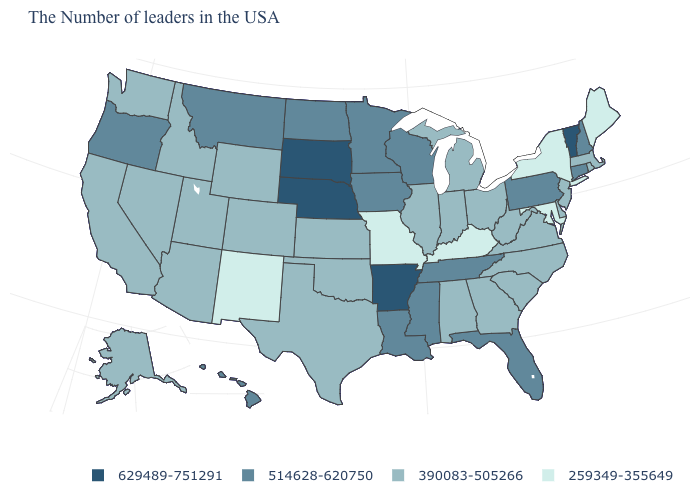Does the map have missing data?
Concise answer only. No. What is the highest value in the USA?
Short answer required. 629489-751291. Name the states that have a value in the range 259349-355649?
Keep it brief. Maine, New York, Maryland, Kentucky, Missouri, New Mexico. What is the value of New York?
Concise answer only. 259349-355649. Does North Carolina have a lower value than Illinois?
Quick response, please. No. Name the states that have a value in the range 390083-505266?
Keep it brief. Massachusetts, Rhode Island, New Jersey, Delaware, Virginia, North Carolina, South Carolina, West Virginia, Ohio, Georgia, Michigan, Indiana, Alabama, Illinois, Kansas, Oklahoma, Texas, Wyoming, Colorado, Utah, Arizona, Idaho, Nevada, California, Washington, Alaska. Name the states that have a value in the range 259349-355649?
Give a very brief answer. Maine, New York, Maryland, Kentucky, Missouri, New Mexico. Name the states that have a value in the range 629489-751291?
Quick response, please. Vermont, Arkansas, Nebraska, South Dakota. Name the states that have a value in the range 390083-505266?
Be succinct. Massachusetts, Rhode Island, New Jersey, Delaware, Virginia, North Carolina, South Carolina, West Virginia, Ohio, Georgia, Michigan, Indiana, Alabama, Illinois, Kansas, Oklahoma, Texas, Wyoming, Colorado, Utah, Arizona, Idaho, Nevada, California, Washington, Alaska. What is the highest value in the USA?
Short answer required. 629489-751291. How many symbols are there in the legend?
Be succinct. 4. Among the states that border New Jersey , does New York have the lowest value?
Answer briefly. Yes. Does the map have missing data?
Answer briefly. No. Name the states that have a value in the range 390083-505266?
Keep it brief. Massachusetts, Rhode Island, New Jersey, Delaware, Virginia, North Carolina, South Carolina, West Virginia, Ohio, Georgia, Michigan, Indiana, Alabama, Illinois, Kansas, Oklahoma, Texas, Wyoming, Colorado, Utah, Arizona, Idaho, Nevada, California, Washington, Alaska. What is the highest value in the USA?
Quick response, please. 629489-751291. 